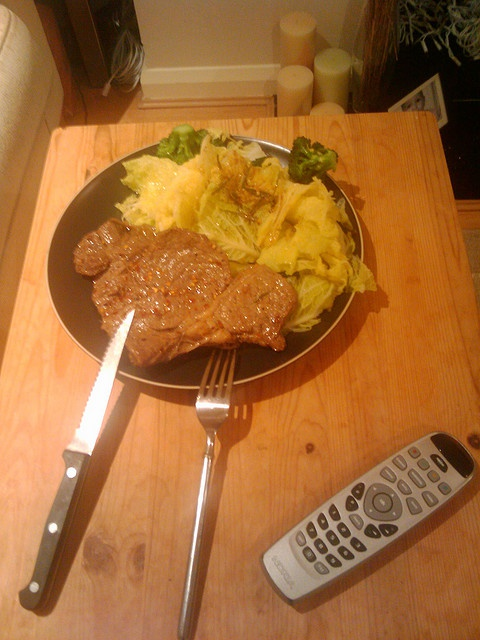Describe the objects in this image and their specific colors. I can see dining table in red, olive, orange, and salmon tones, remote in olive, tan, gray, and maroon tones, potted plant in olive, black, and darkgreen tones, knife in olive, white, brown, gray, and maroon tones, and fork in olive, brown, gray, and white tones in this image. 